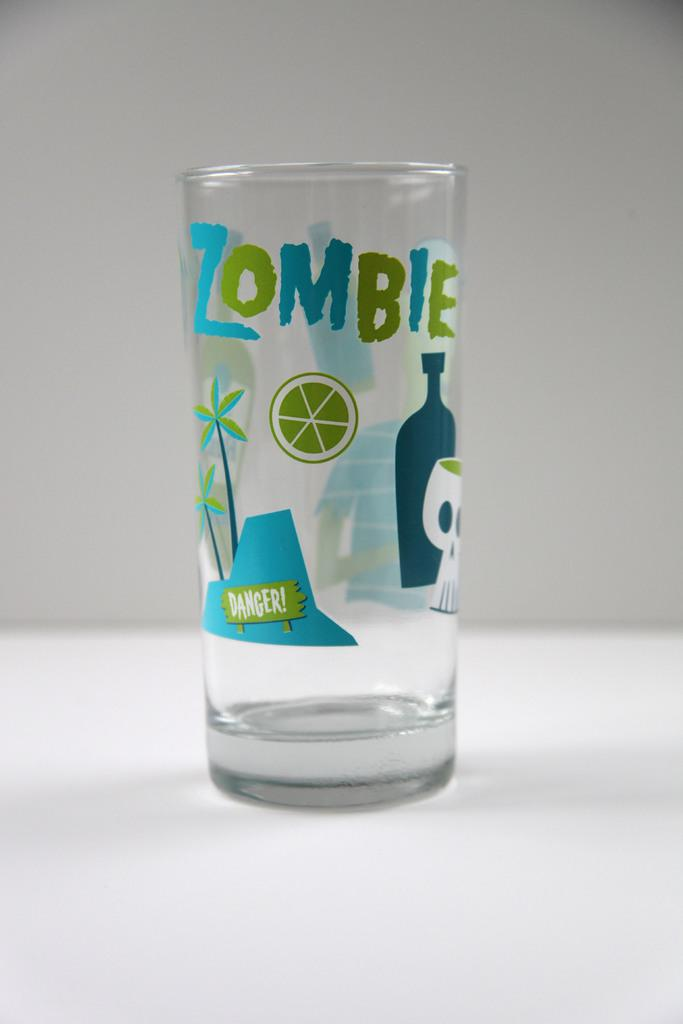Provide a one-sentence caption for the provided image. A glass that has some drawings of plants and skulls that says zombie. 